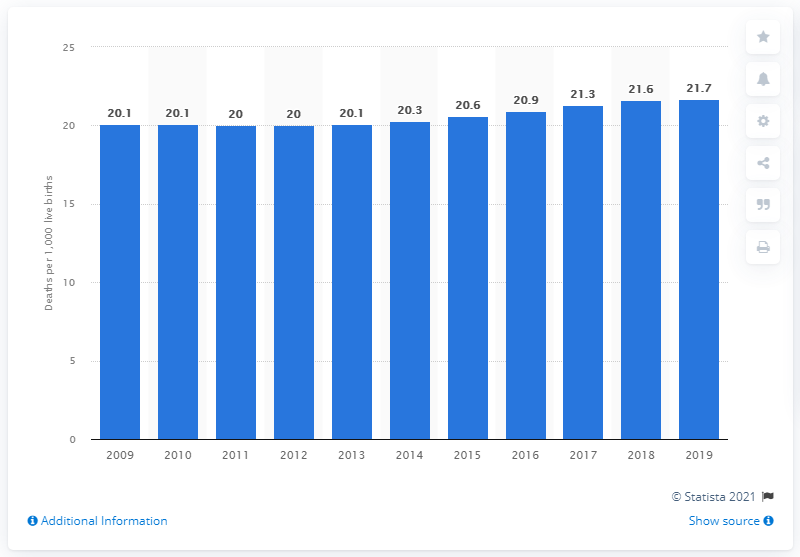Indicate a few pertinent items in this graphic. According to data from 2019, the infant mortality rate in Fiji was 21.7 deaths per 1,000 live births. 